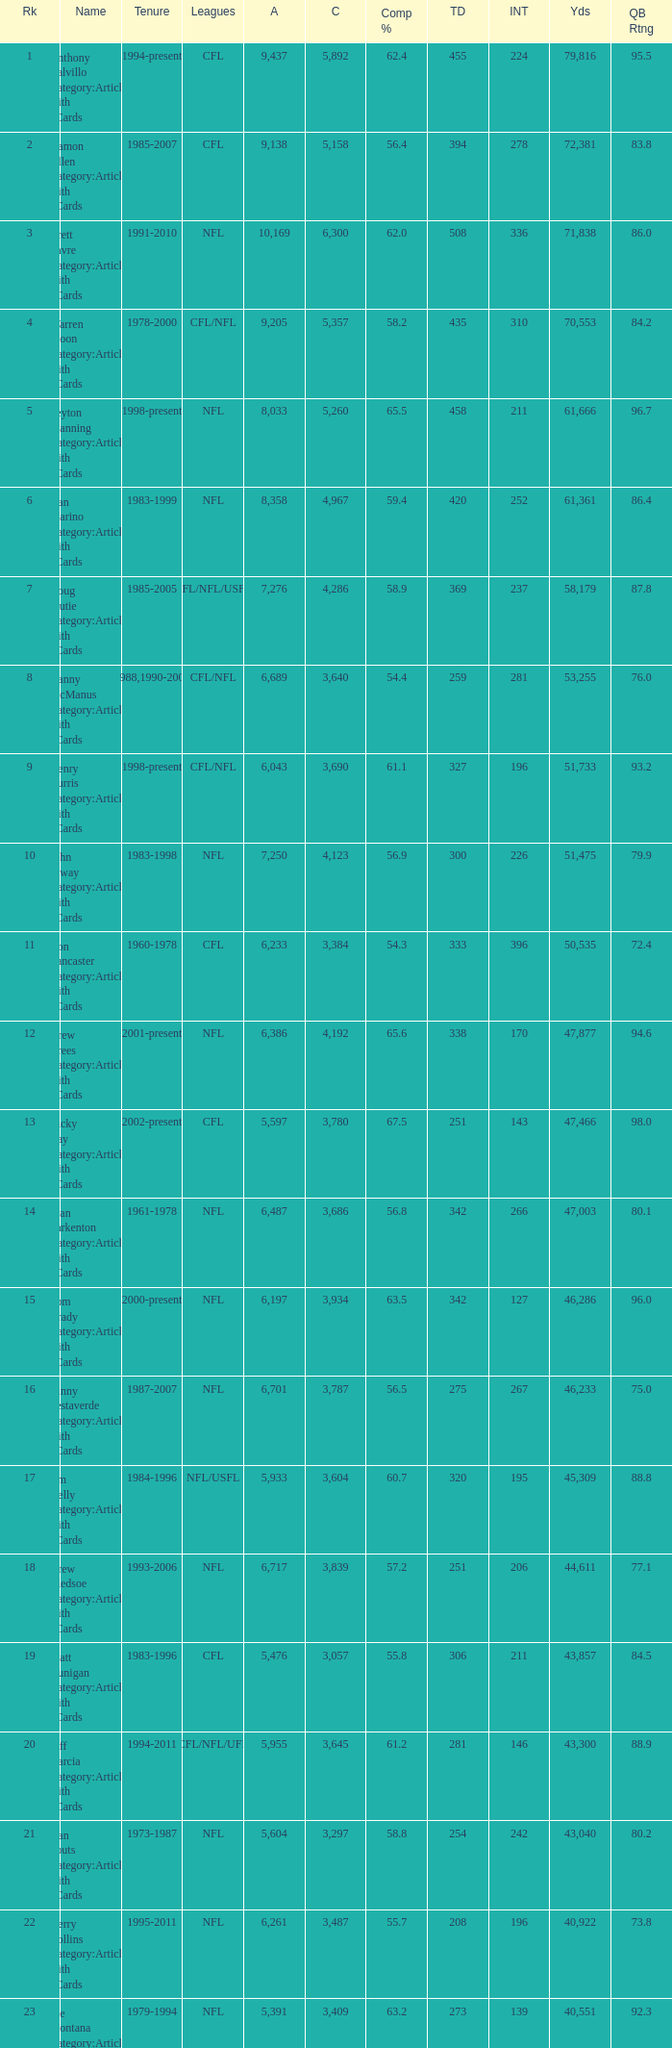What is the quantity of interceptions for players having less than 3,487 completions, greater than 40,551 yards, and a completion rate of 55.8%? 211.0. 